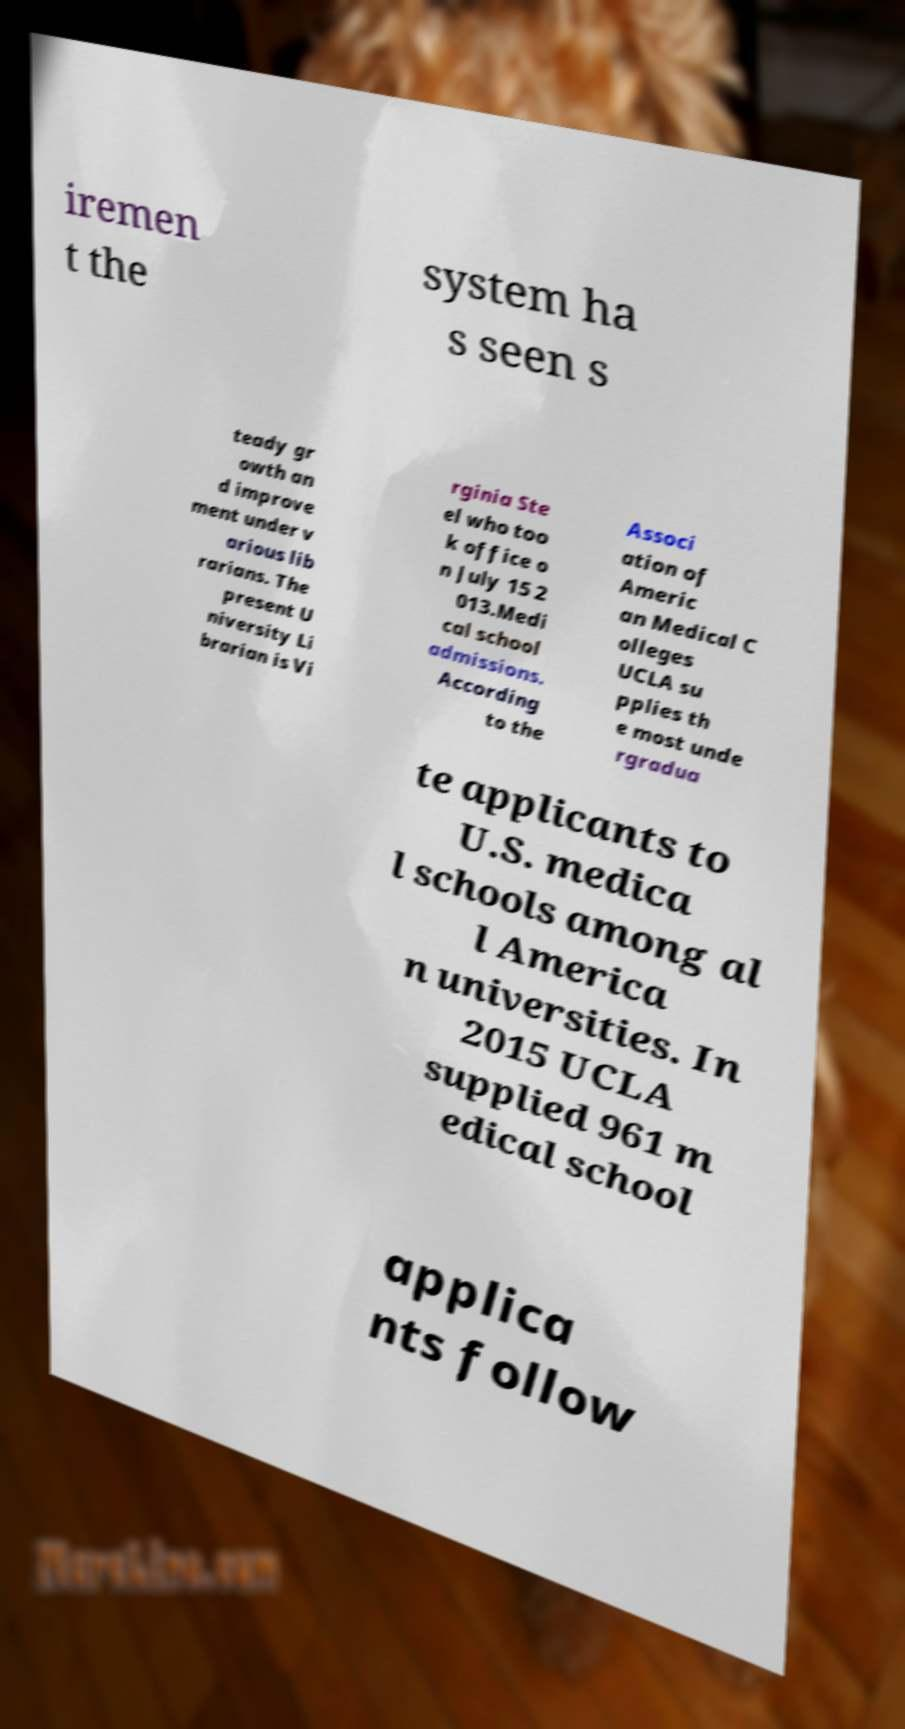For documentation purposes, I need the text within this image transcribed. Could you provide that? iremen t the system ha s seen s teady gr owth an d improve ment under v arious lib rarians. The present U niversity Li brarian is Vi rginia Ste el who too k office o n July 15 2 013.Medi cal school admissions. According to the Associ ation of Americ an Medical C olleges UCLA su pplies th e most unde rgradua te applicants to U.S. medica l schools among al l America n universities. In 2015 UCLA supplied 961 m edical school applica nts follow 